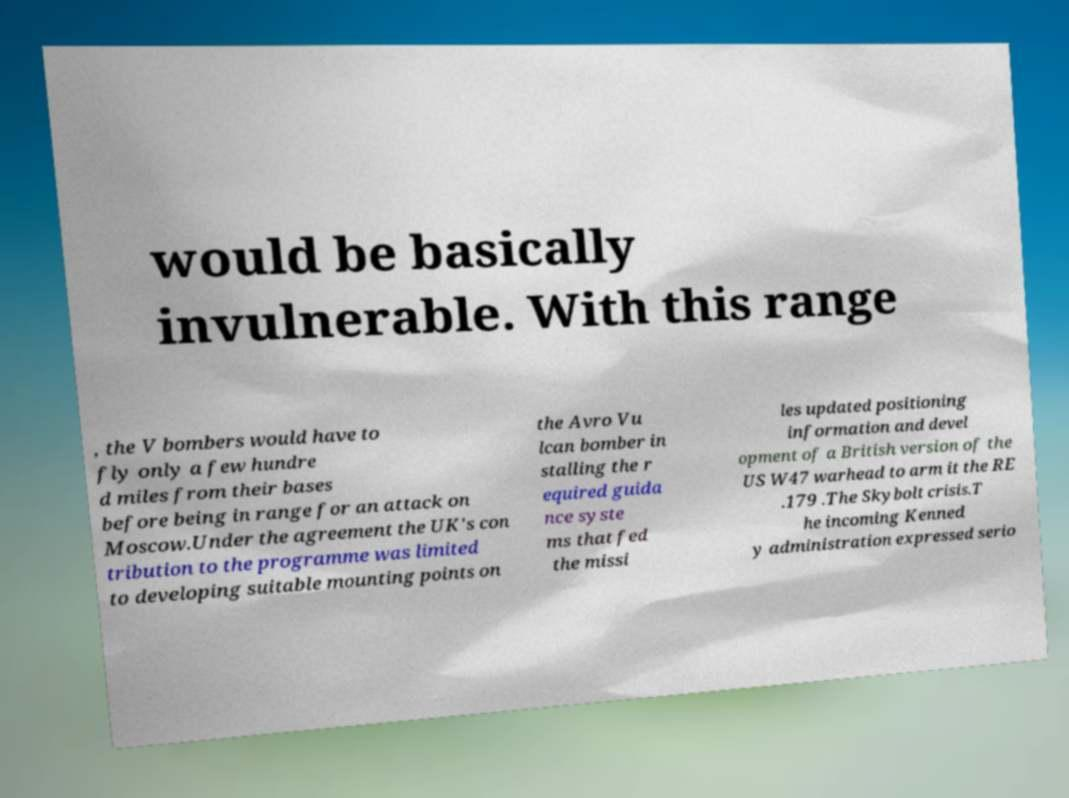For documentation purposes, I need the text within this image transcribed. Could you provide that? would be basically invulnerable. With this range , the V bombers would have to fly only a few hundre d miles from their bases before being in range for an attack on Moscow.Under the agreement the UK's con tribution to the programme was limited to developing suitable mounting points on the Avro Vu lcan bomber in stalling the r equired guida nce syste ms that fed the missi les updated positioning information and devel opment of a British version of the US W47 warhead to arm it the RE .179 .The Skybolt crisis.T he incoming Kenned y administration expressed serio 